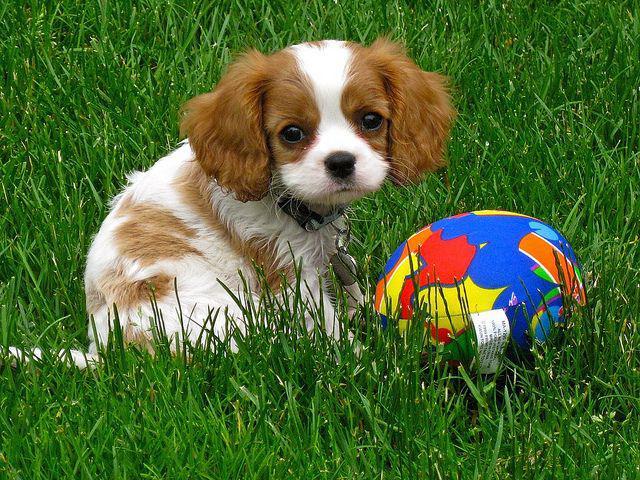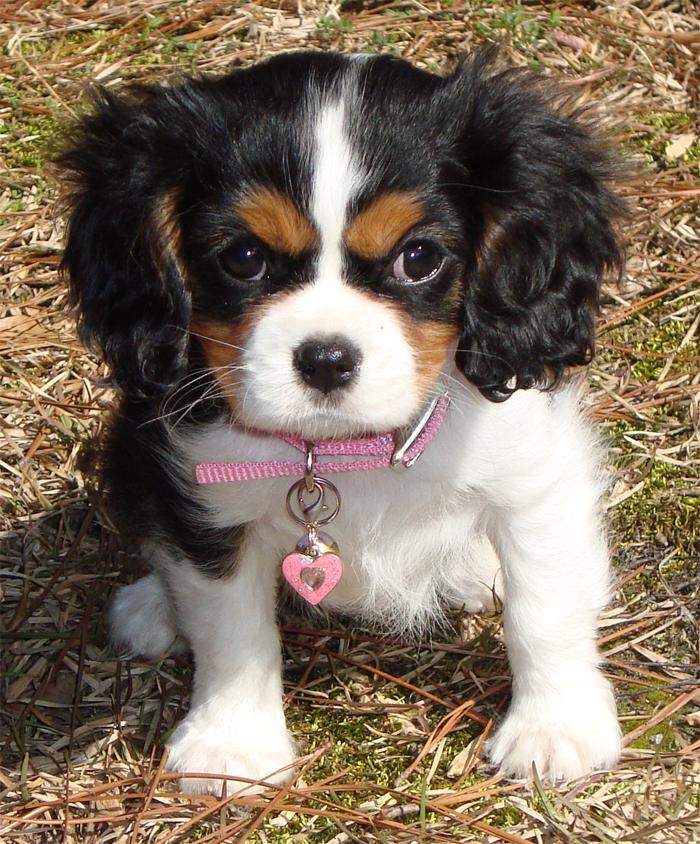The first image is the image on the left, the second image is the image on the right. Given the left and right images, does the statement "There are no more than two puppies." hold true? Answer yes or no. Yes. The first image is the image on the left, the second image is the image on the right. Evaluate the accuracy of this statement regarding the images: "One of the puppies is wearing a collar with pink heart.". Is it true? Answer yes or no. Yes. 